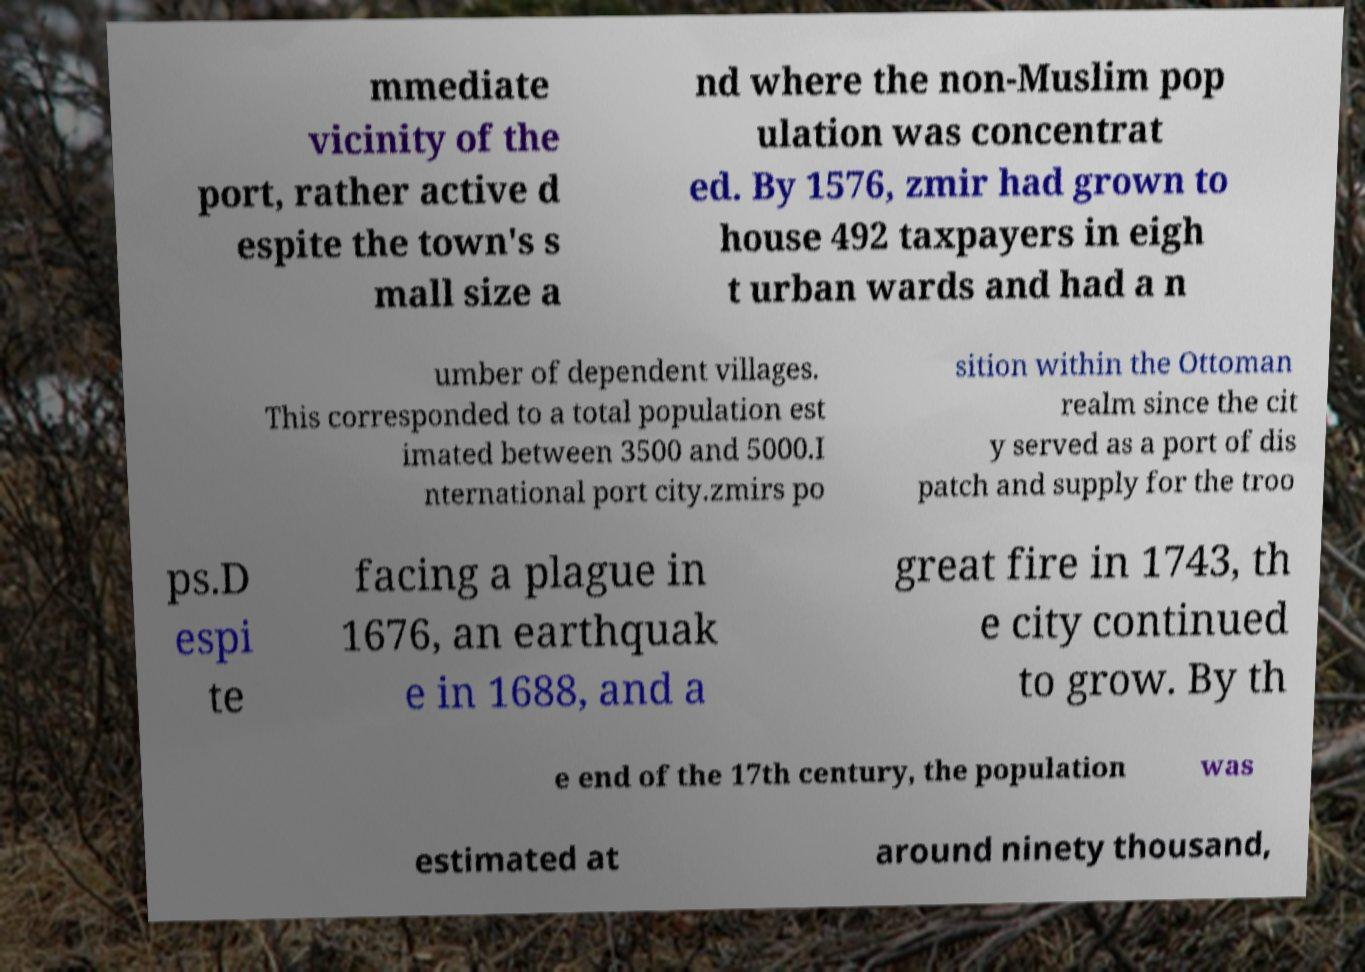Please read and relay the text visible in this image. What does it say? mmediate vicinity of the port, rather active d espite the town's s mall size a nd where the non-Muslim pop ulation was concentrat ed. By 1576, zmir had grown to house 492 taxpayers in eigh t urban wards and had a n umber of dependent villages. This corresponded to a total population est imated between 3500 and 5000.I nternational port city.zmirs po sition within the Ottoman realm since the cit y served as a port of dis patch and supply for the troo ps.D espi te facing a plague in 1676, an earthquak e in 1688, and a great fire in 1743, th e city continued to grow. By th e end of the 17th century, the population was estimated at around ninety thousand, 